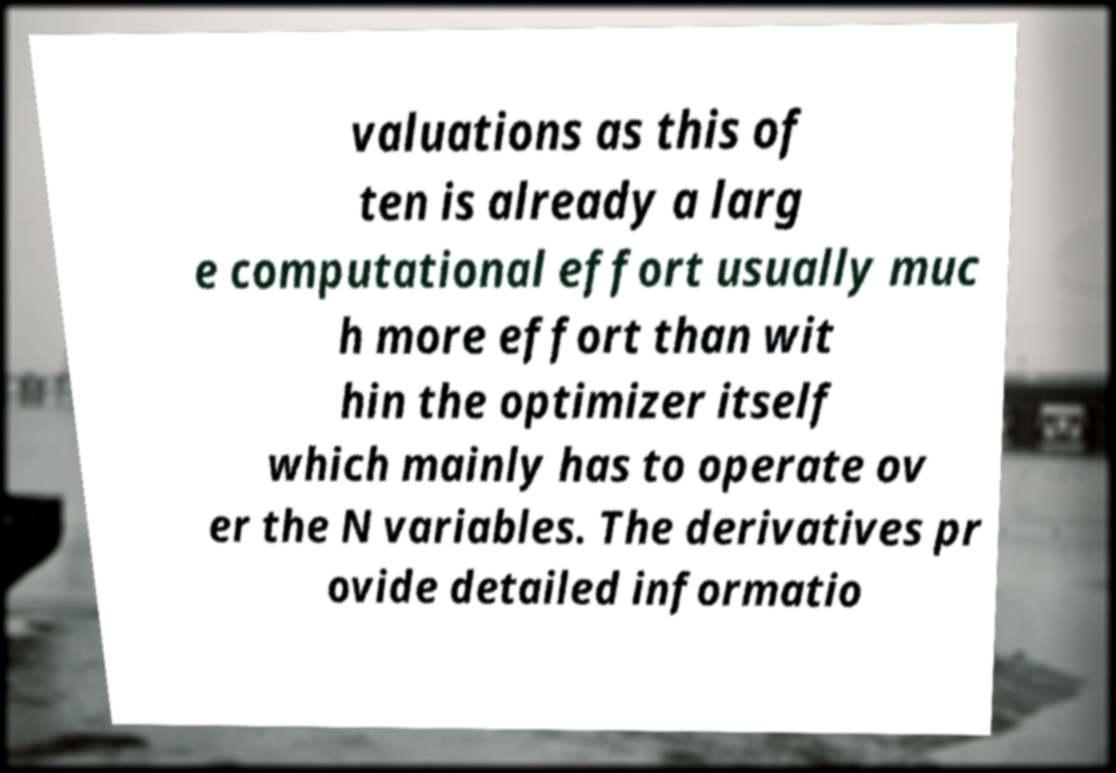Please read and relay the text visible in this image. What does it say? valuations as this of ten is already a larg e computational effort usually muc h more effort than wit hin the optimizer itself which mainly has to operate ov er the N variables. The derivatives pr ovide detailed informatio 